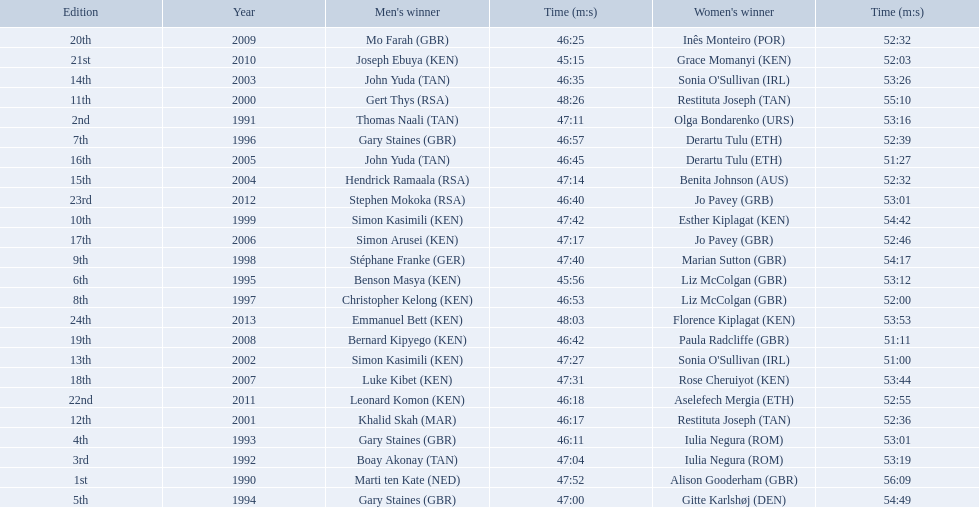Which of the runner in the great south run were women? Alison Gooderham (GBR), Olga Bondarenko (URS), Iulia Negura (ROM), Iulia Negura (ROM), Gitte Karlshøj (DEN), Liz McColgan (GBR), Derartu Tulu (ETH), Liz McColgan (GBR), Marian Sutton (GBR), Esther Kiplagat (KEN), Restituta Joseph (TAN), Restituta Joseph (TAN), Sonia O'Sullivan (IRL), Sonia O'Sullivan (IRL), Benita Johnson (AUS), Derartu Tulu (ETH), Jo Pavey (GBR), Rose Cheruiyot (KEN), Paula Radcliffe (GBR), Inês Monteiro (POR), Grace Momanyi (KEN), Aselefech Mergia (ETH), Jo Pavey (GRB), Florence Kiplagat (KEN). Of those women, which ones had a time of at least 53 minutes? Alison Gooderham (GBR), Olga Bondarenko (URS), Iulia Negura (ROM), Iulia Negura (ROM), Gitte Karlshøj (DEN), Liz McColgan (GBR), Marian Sutton (GBR), Esther Kiplagat (KEN), Restituta Joseph (TAN), Sonia O'Sullivan (IRL), Rose Cheruiyot (KEN), Jo Pavey (GRB), Florence Kiplagat (KEN). Between those women, which ones did not go over 53 minutes? Olga Bondarenko (URS), Iulia Negura (ROM), Iulia Negura (ROM), Liz McColgan (GBR), Sonia O'Sullivan (IRL), Rose Cheruiyot (KEN), Jo Pavey (GRB), Florence Kiplagat (KEN). Of those 8, what were the three slowest times? Sonia O'Sullivan (IRL), Rose Cheruiyot (KEN), Florence Kiplagat (KEN). Between only those 3 women, which runner had the fastest time? Sonia O'Sullivan (IRL). What was this women's time? 53:26. 